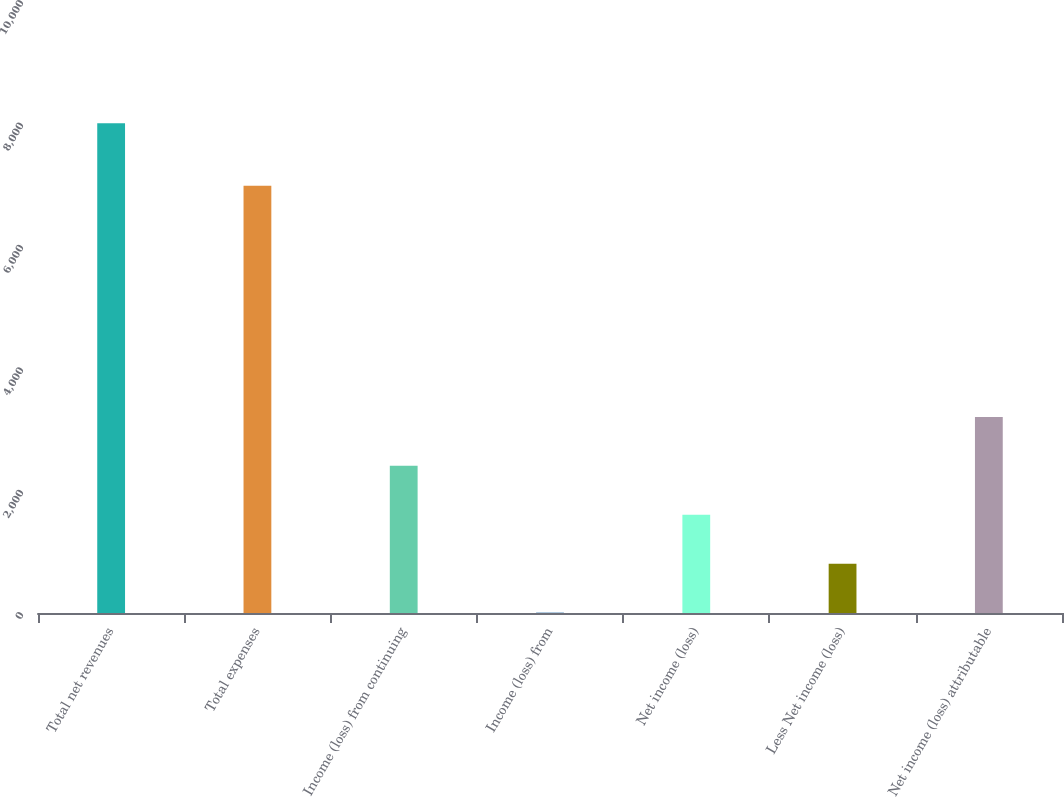Convert chart to OTSL. <chart><loc_0><loc_0><loc_500><loc_500><bar_chart><fcel>Total net revenues<fcel>Total expenses<fcel>Income (loss) from continuing<fcel>Income (loss) from<fcel>Net income (loss)<fcel>Less Net income (loss)<fcel>Net income (loss) attributable<nl><fcel>8001<fcel>6982<fcel>2405.2<fcel>7<fcel>1605.8<fcel>806.4<fcel>3204.6<nl></chart> 